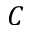Convert formula to latex. <formula><loc_0><loc_0><loc_500><loc_500>C</formula> 